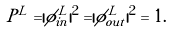Convert formula to latex. <formula><loc_0><loc_0><loc_500><loc_500>P ^ { L } = | \phi ^ { L } _ { i n } | ^ { 2 } = | \phi ^ { L } _ { o u t } | ^ { 2 } = 1 .</formula> 